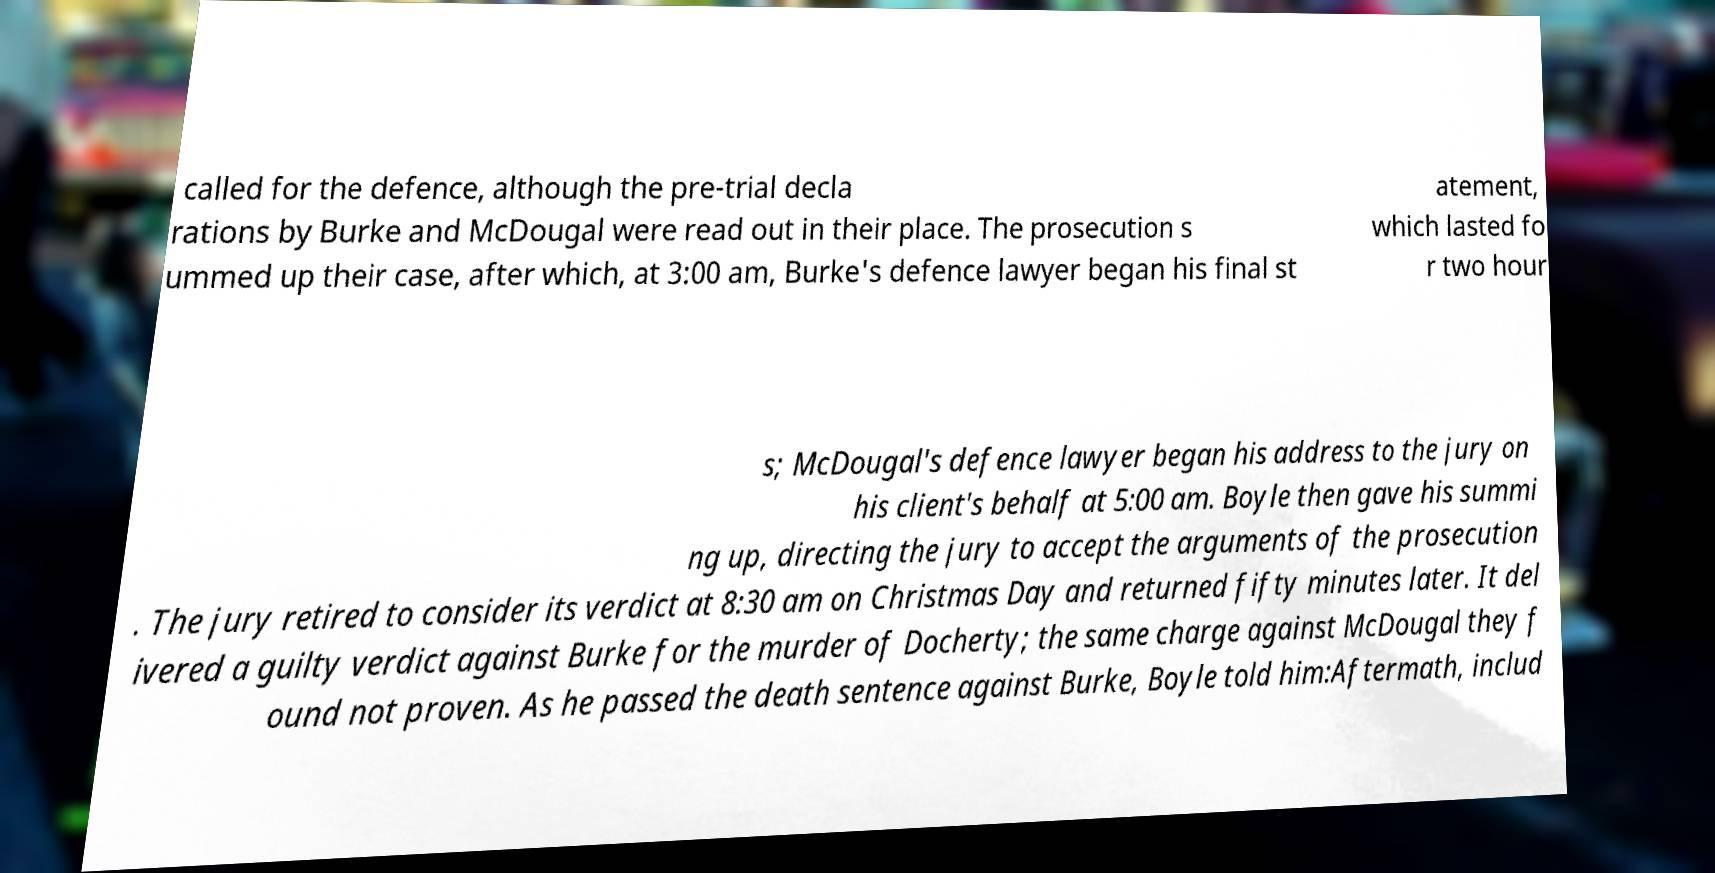I need the written content from this picture converted into text. Can you do that? called for the defence, although the pre-trial decla rations by Burke and McDougal were read out in their place. The prosecution s ummed up their case, after which, at 3:00 am, Burke's defence lawyer began his final st atement, which lasted fo r two hour s; McDougal's defence lawyer began his address to the jury on his client's behalf at 5:00 am. Boyle then gave his summi ng up, directing the jury to accept the arguments of the prosecution . The jury retired to consider its verdict at 8:30 am on Christmas Day and returned fifty minutes later. It del ivered a guilty verdict against Burke for the murder of Docherty; the same charge against McDougal they f ound not proven. As he passed the death sentence against Burke, Boyle told him:Aftermath, includ 